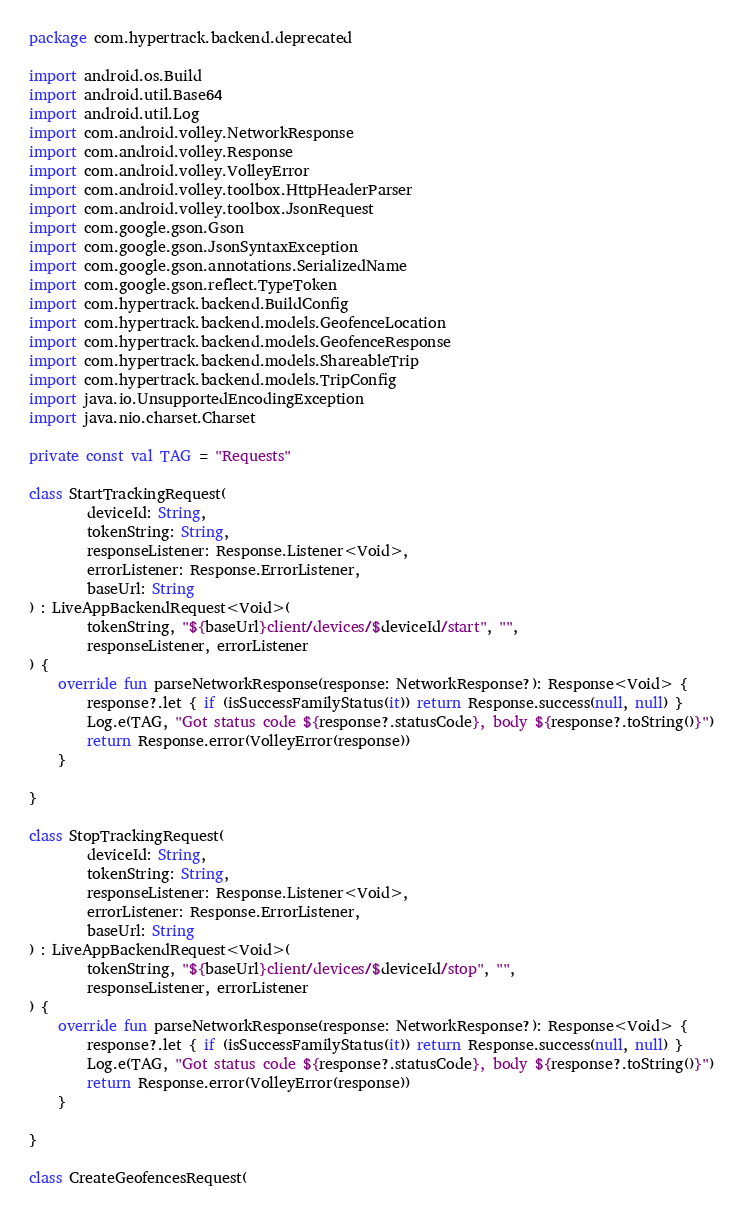Convert code to text. <code><loc_0><loc_0><loc_500><loc_500><_Kotlin_>package com.hypertrack.backend.deprecated

import android.os.Build
import android.util.Base64
import android.util.Log
import com.android.volley.NetworkResponse
import com.android.volley.Response
import com.android.volley.VolleyError
import com.android.volley.toolbox.HttpHeaderParser
import com.android.volley.toolbox.JsonRequest
import com.google.gson.Gson
import com.google.gson.JsonSyntaxException
import com.google.gson.annotations.SerializedName
import com.google.gson.reflect.TypeToken
import com.hypertrack.backend.BuildConfig
import com.hypertrack.backend.models.GeofenceLocation
import com.hypertrack.backend.models.GeofenceResponse
import com.hypertrack.backend.models.ShareableTrip
import com.hypertrack.backend.models.TripConfig
import java.io.UnsupportedEncodingException
import java.nio.charset.Charset

private const val TAG = "Requests"

class StartTrackingRequest(
        deviceId: String,
        tokenString: String,
        responseListener: Response.Listener<Void>,
        errorListener: Response.ErrorListener,
        baseUrl: String
) : LiveAppBackendRequest<Void>(
        tokenString, "${baseUrl}client/devices/$deviceId/start", "",
        responseListener, errorListener
) {
    override fun parseNetworkResponse(response: NetworkResponse?): Response<Void> {
        response?.let { if (isSuccessFamilyStatus(it)) return Response.success(null, null) }
        Log.e(TAG, "Got status code ${response?.statusCode}, body ${response?.toString()}")
        return Response.error(VolleyError(response))
    }

}

class StopTrackingRequest(
        deviceId: String,
        tokenString: String,
        responseListener: Response.Listener<Void>,
        errorListener: Response.ErrorListener,
        baseUrl: String
) : LiveAppBackendRequest<Void>(
        tokenString, "${baseUrl}client/devices/$deviceId/stop", "",
        responseListener, errorListener
) {
    override fun parseNetworkResponse(response: NetworkResponse?): Response<Void> {
        response?.let { if (isSuccessFamilyStatus(it)) return Response.success(null, null) }
        Log.e(TAG, "Got status code ${response?.statusCode}, body ${response?.toString()}")
        return Response.error(VolleyError(response))
    }

}

class CreateGeofencesRequest(</code> 